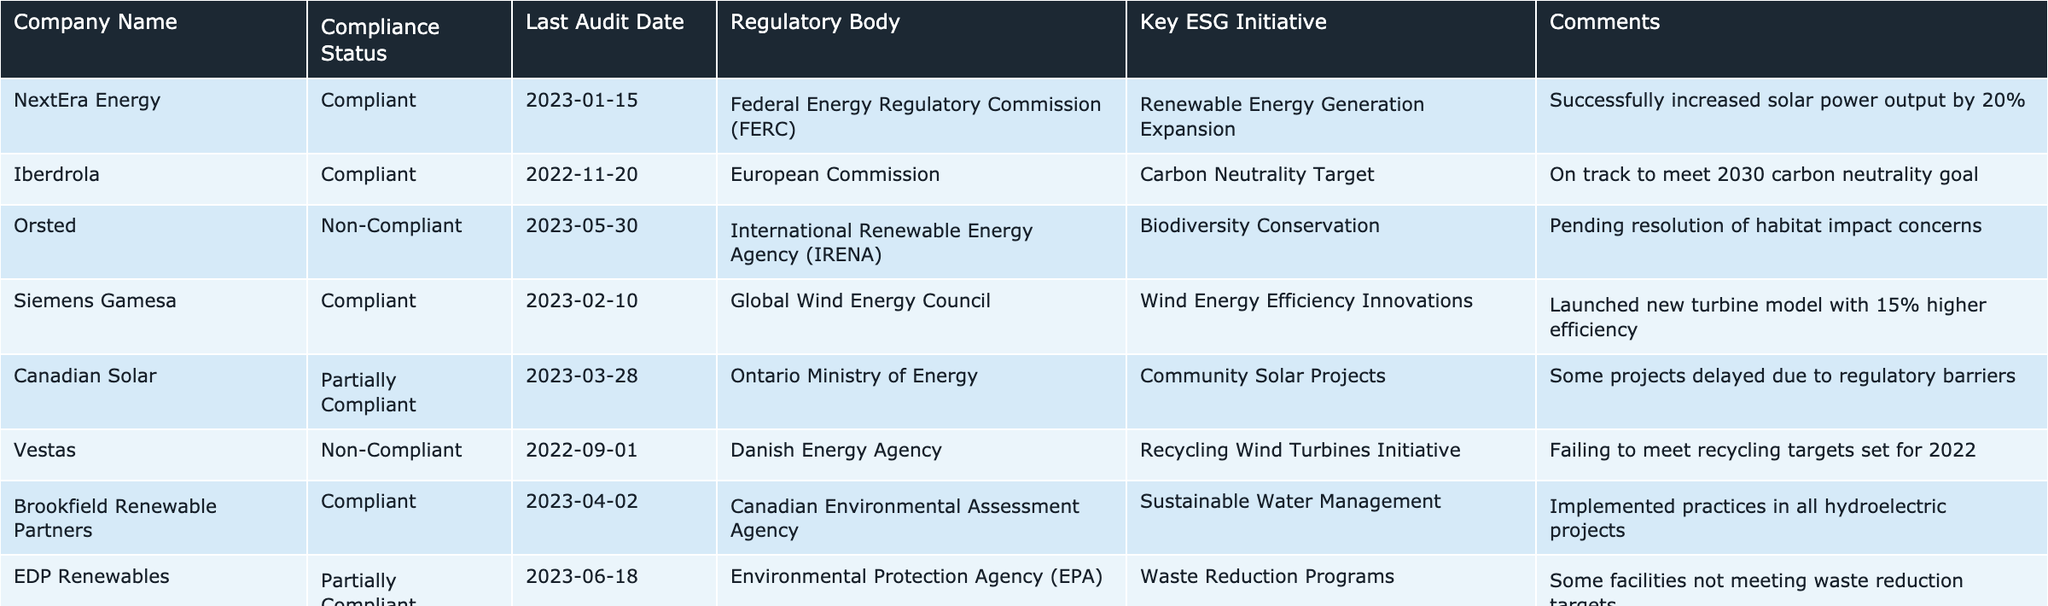What is the compliance status of Canadian Solar? The compliance status of Canadian Solar is listed in the table under the "Compliance Status" column, where it states "Partially Compliant."
Answer: Partially Compliant Which regulatory body audits Siemens Gamesa? The regulatory body responsible for auditing Siemens Gamesa is mentioned in the table under the "Regulatory Body" column, which states "Global Wind Energy Council."
Answer: Global Wind Energy Council How many companies are non-compliant? There are two companies listed as non-compliant in the "Compliance Status" column, which are Orsted and Vestas.
Answer: 2 What was the last audit date for TotalEnergies? The last audit date for TotalEnergies can be found in the "Last Audit Date" column, which indicates "2023-07-05."
Answer: 2023-07-05 Is Iberdrola on track to meet its carbon neutrality goal? The table comments on Iberdrola indicate that it is "On track to meet 2030 carbon neutrality goal," which confirms it is indeed on track.
Answer: Yes What key ESG initiative is associated with Brookfield Renewable Partners? The key ESG initiative for Brookfield Renewable Partners is "Sustainable Water Management" as listed in the relevant column of the table.
Answer: Sustainable Water Management How many companies have implemented waste reduction programs? According to the table, two companies, EDP Renewables and Siemens Gamesa, have key ESG initiatives related to waste reduction programs.
Answer: 1 Which company has the most recent audit date? Among all companies listed, TotalEnergies has the most recent audit date of "2023-07-05," as referenced in the table.
Answer: TotalEnergies What is the main reason for Orsted's non-compliance status? The table states that Orsted is pending resolution of habitat impact concerns under its key ESG initiative for biodiversity conservation, indicating environmental issues as the reason for non-compliance.
Answer: Habitat impact concerns What percentage increase in solar power output did NextEra Energy achieve? The information in the comments section states that NextEra Energy successfully increased its solar power output by 20%, directly answering the question.
Answer: 20% Did any companies have a compliance status of 'Compliant' following their audits in 2023? Upon checking the "Compliance Status" column for 2023 audit dates, NextEra Energy, Siemens Gamesa, and Brookfield Renewable Partners were all compliant.
Answer: Yes 